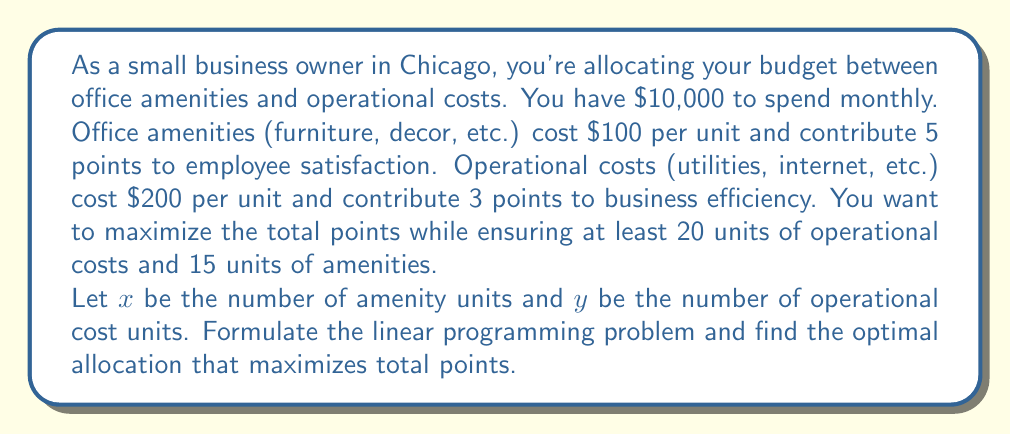Could you help me with this problem? Let's approach this step-by-step:

1) First, we need to define our objective function. We want to maximize total points:
   $$ \text{Maximize } Z = 5x + 3y $$

2) Now, let's list our constraints:

   a) Budget constraint: 
      $$ 100x + 200y \leq 10000 $$
   
   b) Minimum operational costs: 
      $$ y \geq 20 $$
   
   c) Minimum amenities:
      $$ x \geq 15 $$
   
   d) Non-negativity constraints:
      $$ x \geq 0, y \geq 0 $$

3) We can solve this using the graphical method or the simplex method. Let's use the graphical method.

4) Plot the constraints:
   - Budget line: $100x + 200y = 10000$ or $y = 50 - 0.5x$
   - Minimum operational costs: $y = 20$
   - Minimum amenities: $x = 15$

5) The feasible region is the area that satisfies all constraints.

6) The optimal solution will be at one of the corner points of the feasible region. Let's find these points:

   A: (15, 20)
   B: (15, 42.5)
   C: (70, 15)

7) Calculate the objective function value at each point:
   
   A: $Z = 5(15) + 3(20) = 135$
   B: $Z = 5(15) + 3(42.5) = 202.5$
   C: $Z = 5(70) + 3(15) = 395$

8) The maximum value is at point C (70, 15).

Therefore, the optimal allocation is 70 units of amenities and 15 units of operational costs.
Answer: The optimal allocation is 70 units of office amenities and 15 units of operational costs, resulting in a maximum of 395 total points. 